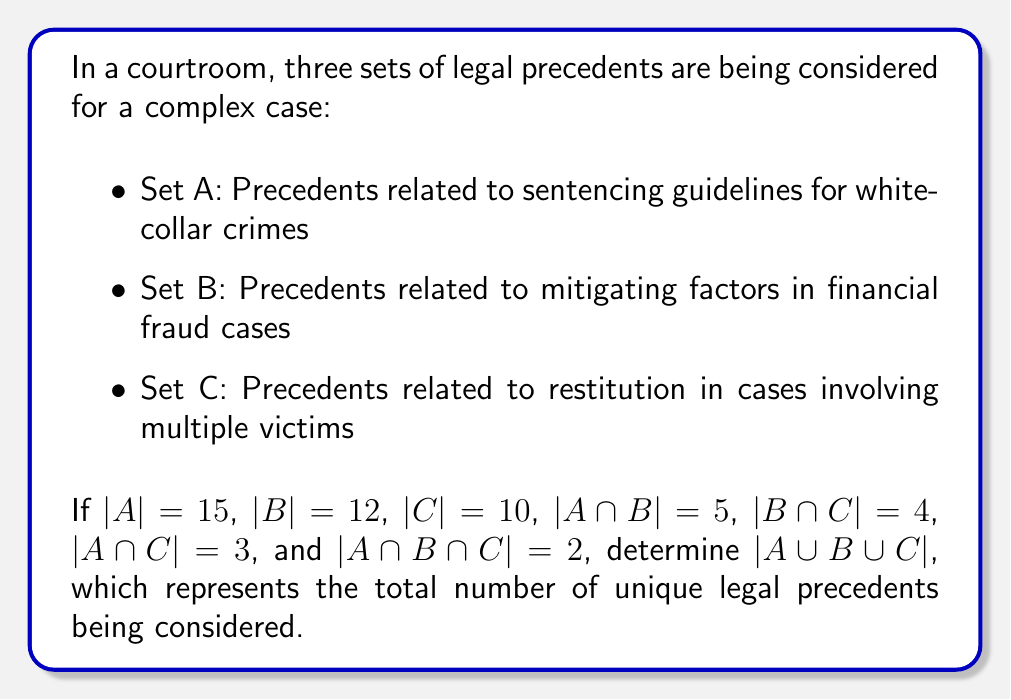Could you help me with this problem? To solve this problem, we'll use the Inclusion-Exclusion Principle for three sets:

$$|A \cup B \cup C| = |A| + |B| + |C| - |A \cap B| - |B \cap C| - |A \cap C| + |A \cap B \cap C|$$

Let's substitute the given values:

1. $|A| = 15$
2. $|B| = 12$
3. $|C| = 10$
4. $|A \cap B| = 5$
5. $|B \cap C| = 4$
6. $|A \cap C| = 3$
7. $|A \cap B \cap C| = 2$

Now, let's calculate:

$$\begin{align*}
|A \cup B \cup C| &= 15 + 12 + 10 - 5 - 4 - 3 + 2 \\
&= 37 - 12 + 2 \\
&= 27
\end{align*}$$

This result represents the total number of unique legal precedents being considered across all three sets, accounting for overlaps between the sets.
Answer: $|A \cup B \cup C| = 27$ 